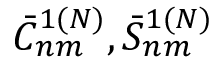<formula> <loc_0><loc_0><loc_500><loc_500>\bar { C } _ { n m } ^ { 1 ( N ) } , \bar { S } _ { n m } ^ { 1 ( N ) }</formula> 